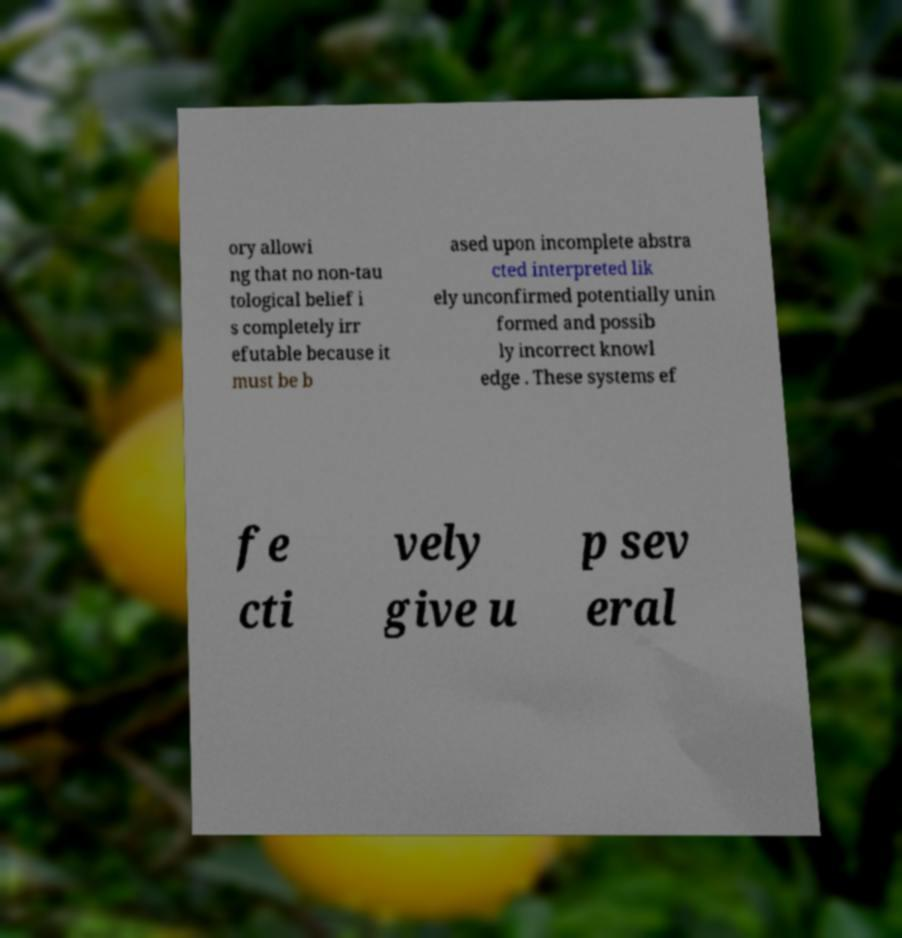Can you accurately transcribe the text from the provided image for me? ory allowi ng that no non-tau tological belief i s completely irr efutable because it must be b ased upon incomplete abstra cted interpreted lik ely unconfirmed potentially unin formed and possib ly incorrect knowl edge . These systems ef fe cti vely give u p sev eral 